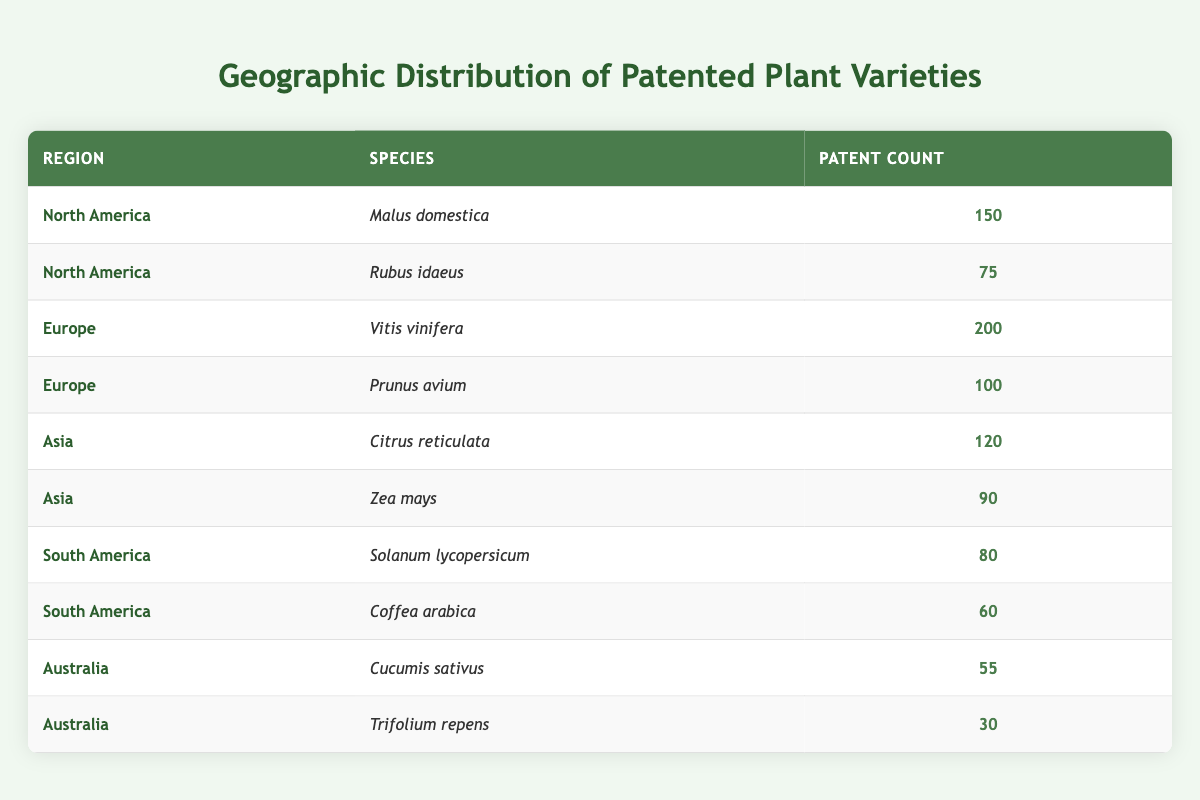What is the total patent count for North America? To find the total patent count for North America, I will look at the rows corresponding to that region. The patent counts for the species in North America are 150 for Malus domestica and 75 for Rubus idaeus. Adding these together gives 150 + 75 = 225.
Answer: 225 Which species has the highest patent count? By examining the patent counts for each species in the table, Vitis vinifera has the highest count at 200, which is greater than the counts for all other species listed.
Answer: Vitis vinifera Is the patent count for Citrus reticulata greater than that for Solanum lycopersicum? The patent count for Citrus reticulata is 120, while that for Solanum lycopersicum is 80. Since 120 is greater than 80, the statement is true.
Answer: Yes What is the average patent count for species in South America? To calculate the average, I need to sum the patent counts for South America: Solanum lycopersicum has 80 and Coffea arabica has 60. The total is 80 + 60 = 140. There are 2 species, so the average is 140 / 2 = 70.
Answer: 70 Are there more patented varieties in Europe than in North America? In Europe, the total patent counts are 200 for Vitis vinifera and 100 for Prunus avium, totaling 300. In North America, the total is 225. Since 300 is greater than 225, the statement is true.
Answer: Yes What is the difference in patent counts between the most and least patented species? The most patented species is Vitis vinifera with 200 patents, and the least is Trifolium repens with 30 patents. The difference is 200 - 30 = 170.
Answer: 170 How many species have a patent count greater than 70? I will look at the patent counts: Malus domestica (150), Rubus idaeus (75), Vitis vinifera (200), Prunus avium (100), Citrus reticulata (120), Zea mays (90), Solanum lycopersicum (80), and Coffea arabica (60). Counting those greater than 70: 150, 75, 200, 100, 120, 90, and 80 totals 7 species. Coffea arabica does not count as it has 60.
Answer: 7 What percentage of the total patents are attributed to species in Asia? The total patents across all regions are 225 (North America) + 300 (Europe) + 210 (Asia) + 140 (South America) + 85 (Australia) = 960. The total for Asia is 210 (120 for Citrus reticulata and 90 for Zea mays). To find the percentage of patents from Asia, I calculate (210 / 960) * 100, which equals approximately 21.88%.
Answer: Approximately 21.88% How many species are patented in Australia? From the table, the two species patented in Australia are Cucumis sativus and Trifolium repens, making it a total of 2 species.
Answer: 2 